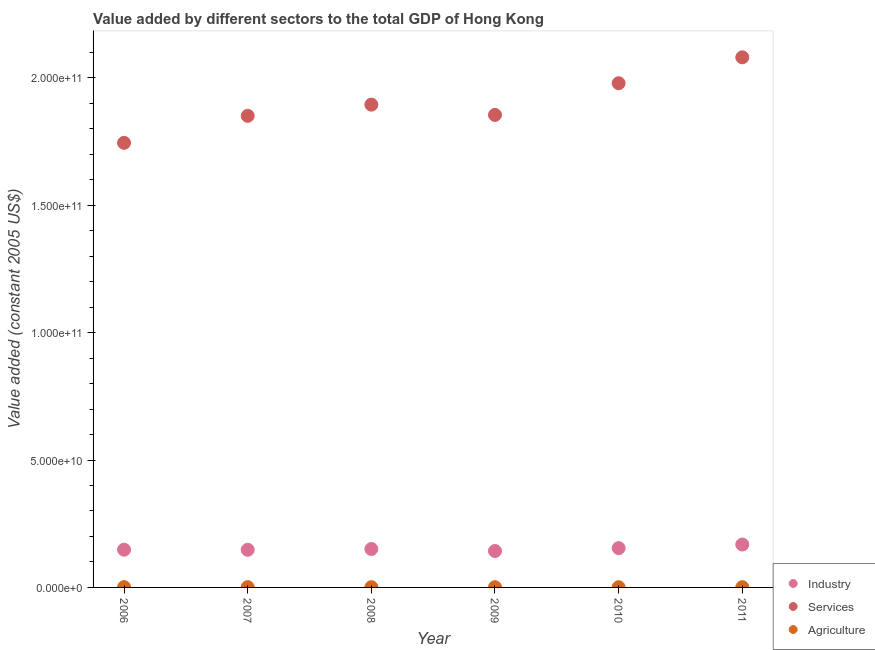What is the value added by industrial sector in 2009?
Give a very brief answer. 1.43e+1. Across all years, what is the maximum value added by agricultural sector?
Offer a terse response. 1.19e+08. Across all years, what is the minimum value added by agricultural sector?
Offer a terse response. 8.99e+07. In which year was the value added by agricultural sector maximum?
Your response must be concise. 2006. In which year was the value added by industrial sector minimum?
Keep it short and to the point. 2009. What is the total value added by industrial sector in the graph?
Your answer should be compact. 9.12e+1. What is the difference between the value added by industrial sector in 2008 and that in 2009?
Offer a very short reply. 7.85e+08. What is the difference between the value added by services in 2007 and the value added by industrial sector in 2010?
Provide a short and direct response. 1.70e+11. What is the average value added by agricultural sector per year?
Make the answer very short. 1.01e+08. In the year 2010, what is the difference between the value added by industrial sector and value added by agricultural sector?
Offer a terse response. 1.53e+1. What is the ratio of the value added by agricultural sector in 2008 to that in 2009?
Provide a succinct answer. 1.05. Is the value added by agricultural sector in 2007 less than that in 2008?
Your response must be concise. No. What is the difference between the highest and the second highest value added by services?
Your response must be concise. 1.02e+1. What is the difference between the highest and the lowest value added by agricultural sector?
Provide a short and direct response. 2.87e+07. Is the sum of the value added by services in 2009 and 2011 greater than the maximum value added by industrial sector across all years?
Provide a succinct answer. Yes. Is it the case that in every year, the sum of the value added by industrial sector and value added by services is greater than the value added by agricultural sector?
Give a very brief answer. Yes. Does the value added by industrial sector monotonically increase over the years?
Keep it short and to the point. No. Is the value added by industrial sector strictly less than the value added by agricultural sector over the years?
Provide a succinct answer. No. How many years are there in the graph?
Offer a terse response. 6. Are the values on the major ticks of Y-axis written in scientific E-notation?
Your answer should be very brief. Yes. Does the graph contain grids?
Your answer should be very brief. No. Where does the legend appear in the graph?
Provide a short and direct response. Bottom right. How many legend labels are there?
Offer a terse response. 3. What is the title of the graph?
Offer a terse response. Value added by different sectors to the total GDP of Hong Kong. What is the label or title of the X-axis?
Keep it short and to the point. Year. What is the label or title of the Y-axis?
Make the answer very short. Value added (constant 2005 US$). What is the Value added (constant 2005 US$) of Industry in 2006?
Your response must be concise. 1.48e+1. What is the Value added (constant 2005 US$) of Services in 2006?
Ensure brevity in your answer.  1.74e+11. What is the Value added (constant 2005 US$) in Agriculture in 2006?
Give a very brief answer. 1.19e+08. What is the Value added (constant 2005 US$) in Industry in 2007?
Your answer should be compact. 1.48e+1. What is the Value added (constant 2005 US$) of Services in 2007?
Keep it short and to the point. 1.85e+11. What is the Value added (constant 2005 US$) in Agriculture in 2007?
Provide a succinct answer. 1.13e+08. What is the Value added (constant 2005 US$) of Industry in 2008?
Your answer should be very brief. 1.51e+1. What is the Value added (constant 2005 US$) of Services in 2008?
Your response must be concise. 1.89e+11. What is the Value added (constant 2005 US$) in Agriculture in 2008?
Give a very brief answer. 9.42e+07. What is the Value added (constant 2005 US$) of Industry in 2009?
Offer a terse response. 1.43e+1. What is the Value added (constant 2005 US$) in Services in 2009?
Ensure brevity in your answer.  1.85e+11. What is the Value added (constant 2005 US$) of Agriculture in 2009?
Provide a succinct answer. 8.99e+07. What is the Value added (constant 2005 US$) of Industry in 2010?
Your answer should be compact. 1.54e+1. What is the Value added (constant 2005 US$) of Services in 2010?
Your response must be concise. 1.98e+11. What is the Value added (constant 2005 US$) of Agriculture in 2010?
Your answer should be compact. 9.32e+07. What is the Value added (constant 2005 US$) in Industry in 2011?
Give a very brief answer. 1.68e+1. What is the Value added (constant 2005 US$) of Services in 2011?
Provide a short and direct response. 2.08e+11. What is the Value added (constant 2005 US$) in Agriculture in 2011?
Provide a succinct answer. 9.38e+07. Across all years, what is the maximum Value added (constant 2005 US$) of Industry?
Your response must be concise. 1.68e+1. Across all years, what is the maximum Value added (constant 2005 US$) in Services?
Your answer should be compact. 2.08e+11. Across all years, what is the maximum Value added (constant 2005 US$) of Agriculture?
Your response must be concise. 1.19e+08. Across all years, what is the minimum Value added (constant 2005 US$) in Industry?
Keep it short and to the point. 1.43e+1. Across all years, what is the minimum Value added (constant 2005 US$) in Services?
Offer a very short reply. 1.74e+11. Across all years, what is the minimum Value added (constant 2005 US$) of Agriculture?
Offer a very short reply. 8.99e+07. What is the total Value added (constant 2005 US$) of Industry in the graph?
Give a very brief answer. 9.12e+1. What is the total Value added (constant 2005 US$) of Services in the graph?
Offer a terse response. 1.14e+12. What is the total Value added (constant 2005 US$) of Agriculture in the graph?
Offer a very short reply. 6.03e+08. What is the difference between the Value added (constant 2005 US$) in Industry in 2006 and that in 2007?
Keep it short and to the point. 4.72e+07. What is the difference between the Value added (constant 2005 US$) of Services in 2006 and that in 2007?
Provide a short and direct response. -1.06e+1. What is the difference between the Value added (constant 2005 US$) in Agriculture in 2006 and that in 2007?
Give a very brief answer. 5.15e+06. What is the difference between the Value added (constant 2005 US$) of Industry in 2006 and that in 2008?
Give a very brief answer. -2.69e+08. What is the difference between the Value added (constant 2005 US$) in Services in 2006 and that in 2008?
Ensure brevity in your answer.  -1.50e+1. What is the difference between the Value added (constant 2005 US$) of Agriculture in 2006 and that in 2008?
Your answer should be compact. 2.43e+07. What is the difference between the Value added (constant 2005 US$) in Industry in 2006 and that in 2009?
Provide a short and direct response. 5.16e+08. What is the difference between the Value added (constant 2005 US$) in Services in 2006 and that in 2009?
Your response must be concise. -1.10e+1. What is the difference between the Value added (constant 2005 US$) of Agriculture in 2006 and that in 2009?
Give a very brief answer. 2.87e+07. What is the difference between the Value added (constant 2005 US$) of Industry in 2006 and that in 2010?
Your response must be concise. -6.21e+08. What is the difference between the Value added (constant 2005 US$) in Services in 2006 and that in 2010?
Give a very brief answer. -2.34e+1. What is the difference between the Value added (constant 2005 US$) in Agriculture in 2006 and that in 2010?
Keep it short and to the point. 2.53e+07. What is the difference between the Value added (constant 2005 US$) of Industry in 2006 and that in 2011?
Keep it short and to the point. -2.03e+09. What is the difference between the Value added (constant 2005 US$) in Services in 2006 and that in 2011?
Offer a terse response. -3.36e+1. What is the difference between the Value added (constant 2005 US$) of Agriculture in 2006 and that in 2011?
Your answer should be compact. 2.47e+07. What is the difference between the Value added (constant 2005 US$) in Industry in 2007 and that in 2008?
Provide a short and direct response. -3.16e+08. What is the difference between the Value added (constant 2005 US$) of Services in 2007 and that in 2008?
Your answer should be very brief. -4.39e+09. What is the difference between the Value added (constant 2005 US$) of Agriculture in 2007 and that in 2008?
Provide a short and direct response. 1.92e+07. What is the difference between the Value added (constant 2005 US$) of Industry in 2007 and that in 2009?
Keep it short and to the point. 4.69e+08. What is the difference between the Value added (constant 2005 US$) in Services in 2007 and that in 2009?
Keep it short and to the point. -3.63e+08. What is the difference between the Value added (constant 2005 US$) in Agriculture in 2007 and that in 2009?
Your response must be concise. 2.36e+07. What is the difference between the Value added (constant 2005 US$) in Industry in 2007 and that in 2010?
Your response must be concise. -6.68e+08. What is the difference between the Value added (constant 2005 US$) in Services in 2007 and that in 2010?
Your answer should be very brief. -1.28e+1. What is the difference between the Value added (constant 2005 US$) in Agriculture in 2007 and that in 2010?
Keep it short and to the point. 2.02e+07. What is the difference between the Value added (constant 2005 US$) in Industry in 2007 and that in 2011?
Provide a short and direct response. -2.08e+09. What is the difference between the Value added (constant 2005 US$) of Services in 2007 and that in 2011?
Your response must be concise. -2.30e+1. What is the difference between the Value added (constant 2005 US$) in Agriculture in 2007 and that in 2011?
Provide a short and direct response. 1.96e+07. What is the difference between the Value added (constant 2005 US$) of Industry in 2008 and that in 2009?
Provide a succinct answer. 7.85e+08. What is the difference between the Value added (constant 2005 US$) in Services in 2008 and that in 2009?
Make the answer very short. 4.03e+09. What is the difference between the Value added (constant 2005 US$) of Agriculture in 2008 and that in 2009?
Provide a short and direct response. 4.37e+06. What is the difference between the Value added (constant 2005 US$) of Industry in 2008 and that in 2010?
Keep it short and to the point. -3.52e+08. What is the difference between the Value added (constant 2005 US$) of Services in 2008 and that in 2010?
Your answer should be very brief. -8.41e+09. What is the difference between the Value added (constant 2005 US$) of Agriculture in 2008 and that in 2010?
Make the answer very short. 1.01e+06. What is the difference between the Value added (constant 2005 US$) in Industry in 2008 and that in 2011?
Make the answer very short. -1.76e+09. What is the difference between the Value added (constant 2005 US$) in Services in 2008 and that in 2011?
Ensure brevity in your answer.  -1.86e+1. What is the difference between the Value added (constant 2005 US$) in Agriculture in 2008 and that in 2011?
Your answer should be compact. 3.90e+05. What is the difference between the Value added (constant 2005 US$) of Industry in 2009 and that in 2010?
Provide a succinct answer. -1.14e+09. What is the difference between the Value added (constant 2005 US$) in Services in 2009 and that in 2010?
Give a very brief answer. -1.24e+1. What is the difference between the Value added (constant 2005 US$) of Agriculture in 2009 and that in 2010?
Ensure brevity in your answer.  -3.35e+06. What is the difference between the Value added (constant 2005 US$) in Industry in 2009 and that in 2011?
Your answer should be very brief. -2.54e+09. What is the difference between the Value added (constant 2005 US$) of Services in 2009 and that in 2011?
Provide a succinct answer. -2.26e+1. What is the difference between the Value added (constant 2005 US$) in Agriculture in 2009 and that in 2011?
Your response must be concise. -3.98e+06. What is the difference between the Value added (constant 2005 US$) in Industry in 2010 and that in 2011?
Your response must be concise. -1.41e+09. What is the difference between the Value added (constant 2005 US$) of Services in 2010 and that in 2011?
Make the answer very short. -1.02e+1. What is the difference between the Value added (constant 2005 US$) in Agriculture in 2010 and that in 2011?
Make the answer very short. -6.24e+05. What is the difference between the Value added (constant 2005 US$) in Industry in 2006 and the Value added (constant 2005 US$) in Services in 2007?
Your response must be concise. -1.70e+11. What is the difference between the Value added (constant 2005 US$) in Industry in 2006 and the Value added (constant 2005 US$) in Agriculture in 2007?
Your response must be concise. 1.47e+1. What is the difference between the Value added (constant 2005 US$) of Services in 2006 and the Value added (constant 2005 US$) of Agriculture in 2007?
Provide a short and direct response. 1.74e+11. What is the difference between the Value added (constant 2005 US$) of Industry in 2006 and the Value added (constant 2005 US$) of Services in 2008?
Give a very brief answer. -1.75e+11. What is the difference between the Value added (constant 2005 US$) in Industry in 2006 and the Value added (constant 2005 US$) in Agriculture in 2008?
Your answer should be very brief. 1.47e+1. What is the difference between the Value added (constant 2005 US$) in Services in 2006 and the Value added (constant 2005 US$) in Agriculture in 2008?
Keep it short and to the point. 1.74e+11. What is the difference between the Value added (constant 2005 US$) of Industry in 2006 and the Value added (constant 2005 US$) of Services in 2009?
Provide a succinct answer. -1.71e+11. What is the difference between the Value added (constant 2005 US$) of Industry in 2006 and the Value added (constant 2005 US$) of Agriculture in 2009?
Make the answer very short. 1.47e+1. What is the difference between the Value added (constant 2005 US$) in Services in 2006 and the Value added (constant 2005 US$) in Agriculture in 2009?
Provide a short and direct response. 1.74e+11. What is the difference between the Value added (constant 2005 US$) of Industry in 2006 and the Value added (constant 2005 US$) of Services in 2010?
Give a very brief answer. -1.83e+11. What is the difference between the Value added (constant 2005 US$) of Industry in 2006 and the Value added (constant 2005 US$) of Agriculture in 2010?
Give a very brief answer. 1.47e+1. What is the difference between the Value added (constant 2005 US$) of Services in 2006 and the Value added (constant 2005 US$) of Agriculture in 2010?
Your answer should be compact. 1.74e+11. What is the difference between the Value added (constant 2005 US$) of Industry in 2006 and the Value added (constant 2005 US$) of Services in 2011?
Keep it short and to the point. -1.93e+11. What is the difference between the Value added (constant 2005 US$) in Industry in 2006 and the Value added (constant 2005 US$) in Agriculture in 2011?
Your response must be concise. 1.47e+1. What is the difference between the Value added (constant 2005 US$) of Services in 2006 and the Value added (constant 2005 US$) of Agriculture in 2011?
Provide a succinct answer. 1.74e+11. What is the difference between the Value added (constant 2005 US$) of Industry in 2007 and the Value added (constant 2005 US$) of Services in 2008?
Provide a succinct answer. -1.75e+11. What is the difference between the Value added (constant 2005 US$) of Industry in 2007 and the Value added (constant 2005 US$) of Agriculture in 2008?
Your answer should be very brief. 1.47e+1. What is the difference between the Value added (constant 2005 US$) in Services in 2007 and the Value added (constant 2005 US$) in Agriculture in 2008?
Provide a short and direct response. 1.85e+11. What is the difference between the Value added (constant 2005 US$) of Industry in 2007 and the Value added (constant 2005 US$) of Services in 2009?
Provide a succinct answer. -1.71e+11. What is the difference between the Value added (constant 2005 US$) in Industry in 2007 and the Value added (constant 2005 US$) in Agriculture in 2009?
Offer a very short reply. 1.47e+1. What is the difference between the Value added (constant 2005 US$) of Services in 2007 and the Value added (constant 2005 US$) of Agriculture in 2009?
Provide a succinct answer. 1.85e+11. What is the difference between the Value added (constant 2005 US$) of Industry in 2007 and the Value added (constant 2005 US$) of Services in 2010?
Provide a succinct answer. -1.83e+11. What is the difference between the Value added (constant 2005 US$) of Industry in 2007 and the Value added (constant 2005 US$) of Agriculture in 2010?
Your answer should be very brief. 1.47e+1. What is the difference between the Value added (constant 2005 US$) of Services in 2007 and the Value added (constant 2005 US$) of Agriculture in 2010?
Ensure brevity in your answer.  1.85e+11. What is the difference between the Value added (constant 2005 US$) in Industry in 2007 and the Value added (constant 2005 US$) in Services in 2011?
Keep it short and to the point. -1.93e+11. What is the difference between the Value added (constant 2005 US$) of Industry in 2007 and the Value added (constant 2005 US$) of Agriculture in 2011?
Provide a short and direct response. 1.47e+1. What is the difference between the Value added (constant 2005 US$) of Services in 2007 and the Value added (constant 2005 US$) of Agriculture in 2011?
Your answer should be very brief. 1.85e+11. What is the difference between the Value added (constant 2005 US$) of Industry in 2008 and the Value added (constant 2005 US$) of Services in 2009?
Make the answer very short. -1.70e+11. What is the difference between the Value added (constant 2005 US$) of Industry in 2008 and the Value added (constant 2005 US$) of Agriculture in 2009?
Your answer should be very brief. 1.50e+1. What is the difference between the Value added (constant 2005 US$) of Services in 2008 and the Value added (constant 2005 US$) of Agriculture in 2009?
Provide a short and direct response. 1.89e+11. What is the difference between the Value added (constant 2005 US$) in Industry in 2008 and the Value added (constant 2005 US$) in Services in 2010?
Ensure brevity in your answer.  -1.83e+11. What is the difference between the Value added (constant 2005 US$) of Industry in 2008 and the Value added (constant 2005 US$) of Agriculture in 2010?
Make the answer very short. 1.50e+1. What is the difference between the Value added (constant 2005 US$) in Services in 2008 and the Value added (constant 2005 US$) in Agriculture in 2010?
Provide a succinct answer. 1.89e+11. What is the difference between the Value added (constant 2005 US$) in Industry in 2008 and the Value added (constant 2005 US$) in Services in 2011?
Provide a short and direct response. -1.93e+11. What is the difference between the Value added (constant 2005 US$) in Industry in 2008 and the Value added (constant 2005 US$) in Agriculture in 2011?
Make the answer very short. 1.50e+1. What is the difference between the Value added (constant 2005 US$) of Services in 2008 and the Value added (constant 2005 US$) of Agriculture in 2011?
Make the answer very short. 1.89e+11. What is the difference between the Value added (constant 2005 US$) in Industry in 2009 and the Value added (constant 2005 US$) in Services in 2010?
Your response must be concise. -1.84e+11. What is the difference between the Value added (constant 2005 US$) of Industry in 2009 and the Value added (constant 2005 US$) of Agriculture in 2010?
Your answer should be very brief. 1.42e+1. What is the difference between the Value added (constant 2005 US$) of Services in 2009 and the Value added (constant 2005 US$) of Agriculture in 2010?
Provide a short and direct response. 1.85e+11. What is the difference between the Value added (constant 2005 US$) of Industry in 2009 and the Value added (constant 2005 US$) of Services in 2011?
Offer a terse response. -1.94e+11. What is the difference between the Value added (constant 2005 US$) in Industry in 2009 and the Value added (constant 2005 US$) in Agriculture in 2011?
Your response must be concise. 1.42e+1. What is the difference between the Value added (constant 2005 US$) of Services in 2009 and the Value added (constant 2005 US$) of Agriculture in 2011?
Offer a very short reply. 1.85e+11. What is the difference between the Value added (constant 2005 US$) of Industry in 2010 and the Value added (constant 2005 US$) of Services in 2011?
Keep it short and to the point. -1.93e+11. What is the difference between the Value added (constant 2005 US$) of Industry in 2010 and the Value added (constant 2005 US$) of Agriculture in 2011?
Offer a very short reply. 1.53e+1. What is the difference between the Value added (constant 2005 US$) of Services in 2010 and the Value added (constant 2005 US$) of Agriculture in 2011?
Provide a succinct answer. 1.98e+11. What is the average Value added (constant 2005 US$) in Industry per year?
Give a very brief answer. 1.52e+1. What is the average Value added (constant 2005 US$) of Services per year?
Make the answer very short. 1.90e+11. What is the average Value added (constant 2005 US$) in Agriculture per year?
Give a very brief answer. 1.01e+08. In the year 2006, what is the difference between the Value added (constant 2005 US$) of Industry and Value added (constant 2005 US$) of Services?
Provide a succinct answer. -1.60e+11. In the year 2006, what is the difference between the Value added (constant 2005 US$) in Industry and Value added (constant 2005 US$) in Agriculture?
Ensure brevity in your answer.  1.47e+1. In the year 2006, what is the difference between the Value added (constant 2005 US$) in Services and Value added (constant 2005 US$) in Agriculture?
Your response must be concise. 1.74e+11. In the year 2007, what is the difference between the Value added (constant 2005 US$) of Industry and Value added (constant 2005 US$) of Services?
Keep it short and to the point. -1.70e+11. In the year 2007, what is the difference between the Value added (constant 2005 US$) of Industry and Value added (constant 2005 US$) of Agriculture?
Keep it short and to the point. 1.46e+1. In the year 2007, what is the difference between the Value added (constant 2005 US$) of Services and Value added (constant 2005 US$) of Agriculture?
Give a very brief answer. 1.85e+11. In the year 2008, what is the difference between the Value added (constant 2005 US$) of Industry and Value added (constant 2005 US$) of Services?
Provide a succinct answer. -1.74e+11. In the year 2008, what is the difference between the Value added (constant 2005 US$) in Industry and Value added (constant 2005 US$) in Agriculture?
Offer a very short reply. 1.50e+1. In the year 2008, what is the difference between the Value added (constant 2005 US$) of Services and Value added (constant 2005 US$) of Agriculture?
Provide a succinct answer. 1.89e+11. In the year 2009, what is the difference between the Value added (constant 2005 US$) in Industry and Value added (constant 2005 US$) in Services?
Your response must be concise. -1.71e+11. In the year 2009, what is the difference between the Value added (constant 2005 US$) of Industry and Value added (constant 2005 US$) of Agriculture?
Your answer should be compact. 1.42e+1. In the year 2009, what is the difference between the Value added (constant 2005 US$) in Services and Value added (constant 2005 US$) in Agriculture?
Your response must be concise. 1.85e+11. In the year 2010, what is the difference between the Value added (constant 2005 US$) in Industry and Value added (constant 2005 US$) in Services?
Keep it short and to the point. -1.82e+11. In the year 2010, what is the difference between the Value added (constant 2005 US$) in Industry and Value added (constant 2005 US$) in Agriculture?
Make the answer very short. 1.53e+1. In the year 2010, what is the difference between the Value added (constant 2005 US$) in Services and Value added (constant 2005 US$) in Agriculture?
Give a very brief answer. 1.98e+11. In the year 2011, what is the difference between the Value added (constant 2005 US$) of Industry and Value added (constant 2005 US$) of Services?
Provide a short and direct response. -1.91e+11. In the year 2011, what is the difference between the Value added (constant 2005 US$) of Industry and Value added (constant 2005 US$) of Agriculture?
Your answer should be very brief. 1.67e+1. In the year 2011, what is the difference between the Value added (constant 2005 US$) of Services and Value added (constant 2005 US$) of Agriculture?
Keep it short and to the point. 2.08e+11. What is the ratio of the Value added (constant 2005 US$) in Services in 2006 to that in 2007?
Offer a terse response. 0.94. What is the ratio of the Value added (constant 2005 US$) of Agriculture in 2006 to that in 2007?
Your answer should be very brief. 1.05. What is the ratio of the Value added (constant 2005 US$) of Industry in 2006 to that in 2008?
Give a very brief answer. 0.98. What is the ratio of the Value added (constant 2005 US$) of Services in 2006 to that in 2008?
Offer a very short reply. 0.92. What is the ratio of the Value added (constant 2005 US$) of Agriculture in 2006 to that in 2008?
Keep it short and to the point. 1.26. What is the ratio of the Value added (constant 2005 US$) of Industry in 2006 to that in 2009?
Give a very brief answer. 1.04. What is the ratio of the Value added (constant 2005 US$) of Services in 2006 to that in 2009?
Make the answer very short. 0.94. What is the ratio of the Value added (constant 2005 US$) of Agriculture in 2006 to that in 2009?
Ensure brevity in your answer.  1.32. What is the ratio of the Value added (constant 2005 US$) in Industry in 2006 to that in 2010?
Provide a short and direct response. 0.96. What is the ratio of the Value added (constant 2005 US$) in Services in 2006 to that in 2010?
Ensure brevity in your answer.  0.88. What is the ratio of the Value added (constant 2005 US$) of Agriculture in 2006 to that in 2010?
Your response must be concise. 1.27. What is the ratio of the Value added (constant 2005 US$) of Industry in 2006 to that in 2011?
Give a very brief answer. 0.88. What is the ratio of the Value added (constant 2005 US$) of Services in 2006 to that in 2011?
Provide a short and direct response. 0.84. What is the ratio of the Value added (constant 2005 US$) in Agriculture in 2006 to that in 2011?
Offer a very short reply. 1.26. What is the ratio of the Value added (constant 2005 US$) of Industry in 2007 to that in 2008?
Your answer should be very brief. 0.98. What is the ratio of the Value added (constant 2005 US$) in Services in 2007 to that in 2008?
Give a very brief answer. 0.98. What is the ratio of the Value added (constant 2005 US$) in Agriculture in 2007 to that in 2008?
Offer a very short reply. 1.2. What is the ratio of the Value added (constant 2005 US$) in Industry in 2007 to that in 2009?
Your answer should be very brief. 1.03. What is the ratio of the Value added (constant 2005 US$) in Agriculture in 2007 to that in 2009?
Keep it short and to the point. 1.26. What is the ratio of the Value added (constant 2005 US$) of Industry in 2007 to that in 2010?
Your response must be concise. 0.96. What is the ratio of the Value added (constant 2005 US$) of Services in 2007 to that in 2010?
Your response must be concise. 0.94. What is the ratio of the Value added (constant 2005 US$) in Agriculture in 2007 to that in 2010?
Offer a terse response. 1.22. What is the ratio of the Value added (constant 2005 US$) in Industry in 2007 to that in 2011?
Offer a terse response. 0.88. What is the ratio of the Value added (constant 2005 US$) in Services in 2007 to that in 2011?
Provide a succinct answer. 0.89. What is the ratio of the Value added (constant 2005 US$) in Agriculture in 2007 to that in 2011?
Your answer should be compact. 1.21. What is the ratio of the Value added (constant 2005 US$) of Industry in 2008 to that in 2009?
Your response must be concise. 1.05. What is the ratio of the Value added (constant 2005 US$) of Services in 2008 to that in 2009?
Ensure brevity in your answer.  1.02. What is the ratio of the Value added (constant 2005 US$) in Agriculture in 2008 to that in 2009?
Your answer should be very brief. 1.05. What is the ratio of the Value added (constant 2005 US$) of Industry in 2008 to that in 2010?
Offer a very short reply. 0.98. What is the ratio of the Value added (constant 2005 US$) of Services in 2008 to that in 2010?
Offer a terse response. 0.96. What is the ratio of the Value added (constant 2005 US$) in Agriculture in 2008 to that in 2010?
Give a very brief answer. 1.01. What is the ratio of the Value added (constant 2005 US$) in Industry in 2008 to that in 2011?
Keep it short and to the point. 0.9. What is the ratio of the Value added (constant 2005 US$) in Services in 2008 to that in 2011?
Offer a terse response. 0.91. What is the ratio of the Value added (constant 2005 US$) in Agriculture in 2008 to that in 2011?
Offer a very short reply. 1. What is the ratio of the Value added (constant 2005 US$) of Industry in 2009 to that in 2010?
Offer a very short reply. 0.93. What is the ratio of the Value added (constant 2005 US$) of Services in 2009 to that in 2010?
Your answer should be very brief. 0.94. What is the ratio of the Value added (constant 2005 US$) of Industry in 2009 to that in 2011?
Your answer should be very brief. 0.85. What is the ratio of the Value added (constant 2005 US$) of Services in 2009 to that in 2011?
Your answer should be very brief. 0.89. What is the ratio of the Value added (constant 2005 US$) of Agriculture in 2009 to that in 2011?
Keep it short and to the point. 0.96. What is the ratio of the Value added (constant 2005 US$) in Industry in 2010 to that in 2011?
Give a very brief answer. 0.92. What is the ratio of the Value added (constant 2005 US$) in Services in 2010 to that in 2011?
Ensure brevity in your answer.  0.95. What is the difference between the highest and the second highest Value added (constant 2005 US$) in Industry?
Provide a succinct answer. 1.41e+09. What is the difference between the highest and the second highest Value added (constant 2005 US$) in Services?
Your answer should be compact. 1.02e+1. What is the difference between the highest and the second highest Value added (constant 2005 US$) of Agriculture?
Make the answer very short. 5.15e+06. What is the difference between the highest and the lowest Value added (constant 2005 US$) of Industry?
Ensure brevity in your answer.  2.54e+09. What is the difference between the highest and the lowest Value added (constant 2005 US$) of Services?
Offer a terse response. 3.36e+1. What is the difference between the highest and the lowest Value added (constant 2005 US$) in Agriculture?
Make the answer very short. 2.87e+07. 